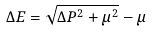<formula> <loc_0><loc_0><loc_500><loc_500>\Delta E = \sqrt { \Delta P ^ { 2 } + \mu ^ { 2 } } - \mu</formula> 